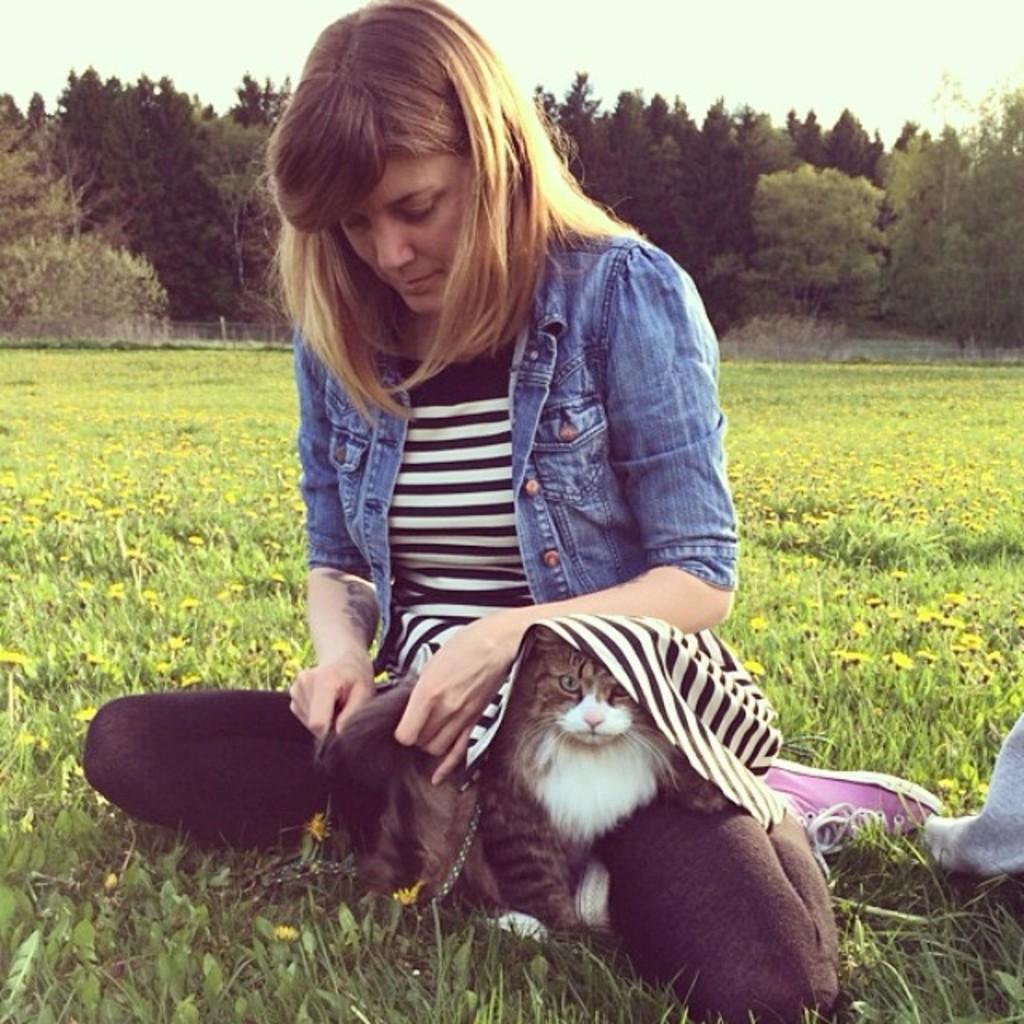Please provide a concise description of this image. In this image I can see a woman sitting in the garden with a cat. At the background we can see a tree and a sky. 